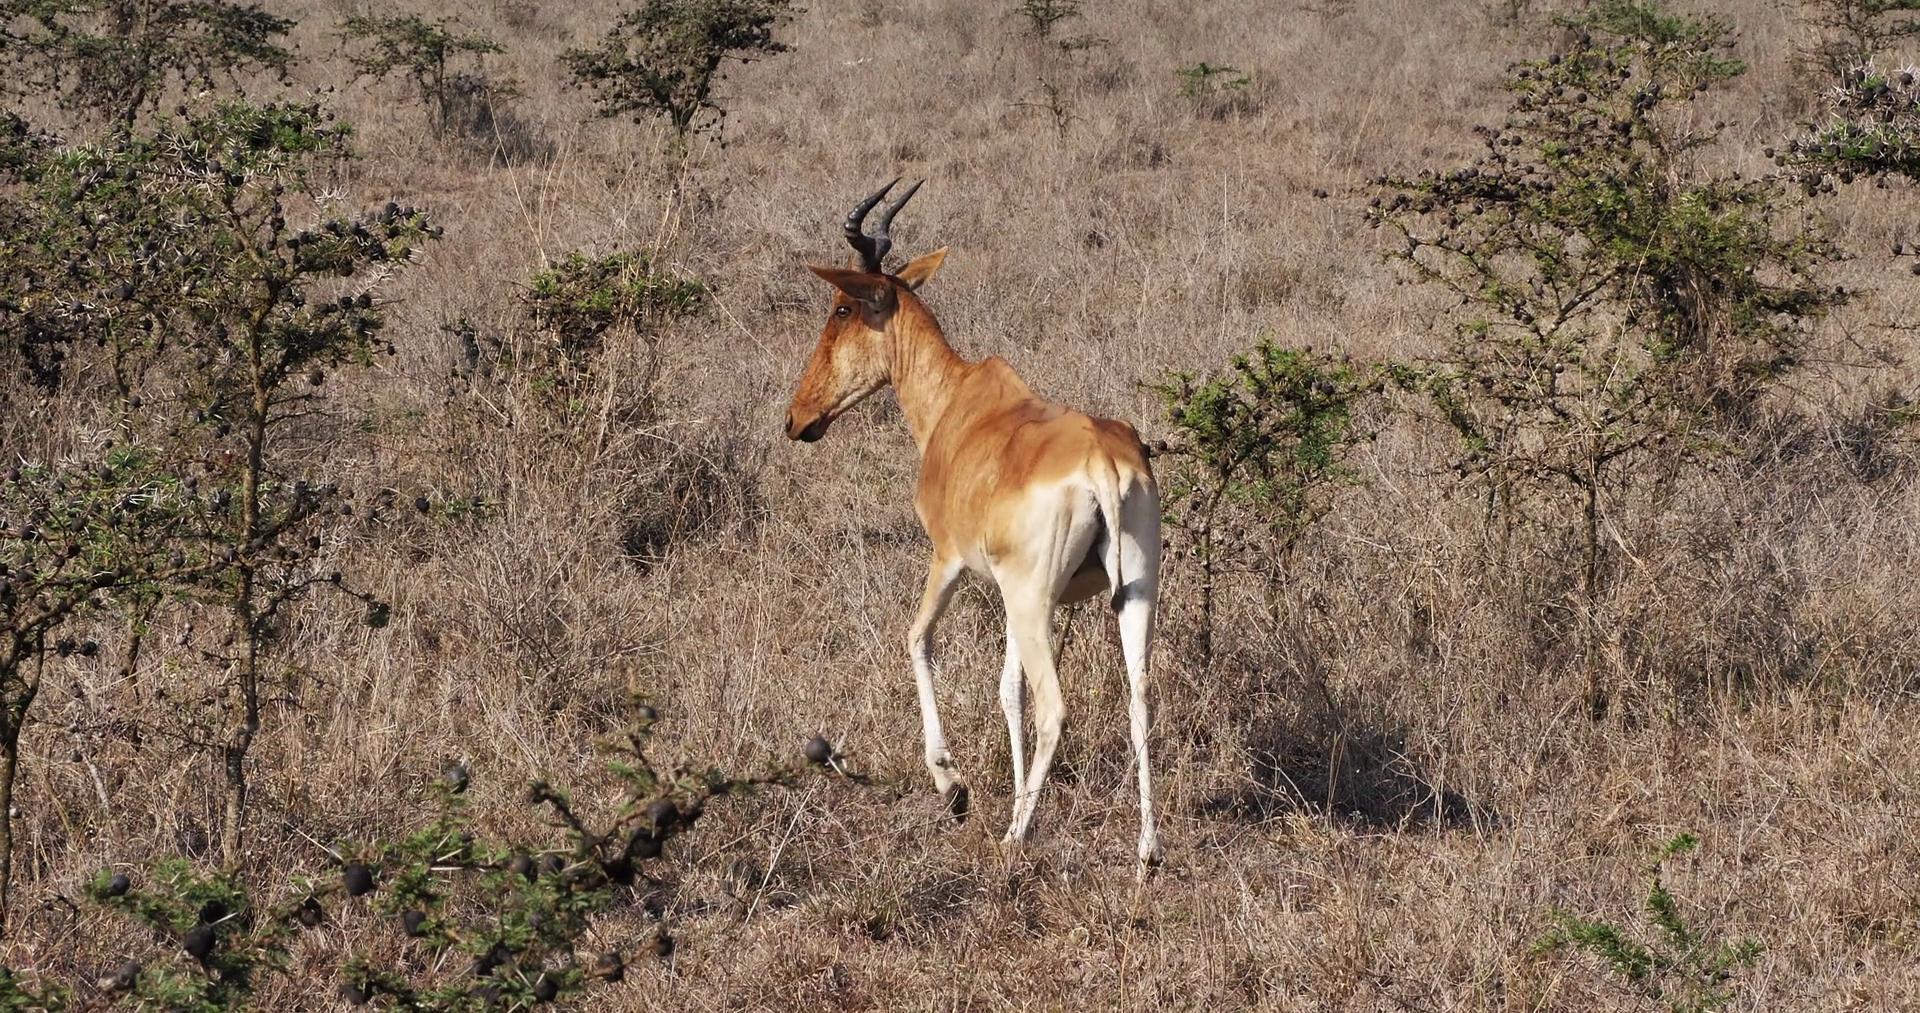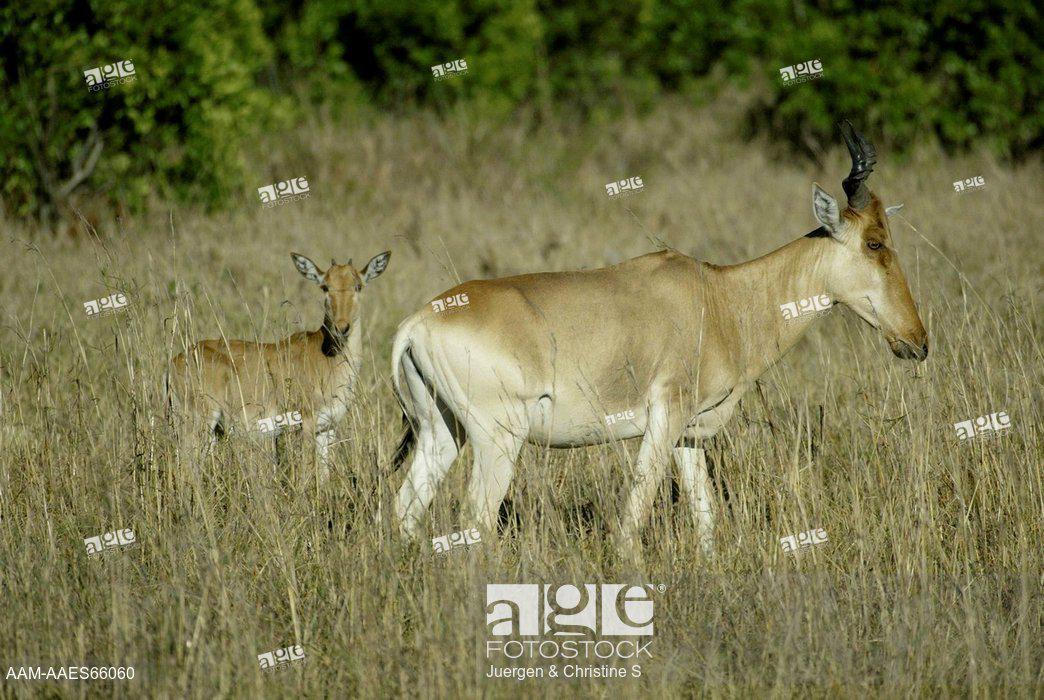The first image is the image on the left, the second image is the image on the right. Evaluate the accuracy of this statement regarding the images: "The left image contains at least three antelopes.". Is it true? Answer yes or no. No. The first image is the image on the left, the second image is the image on the right. Evaluate the accuracy of this statement regarding the images: "Three horned animals in standing poses are in the image on the left.". Is it true? Answer yes or no. No. 